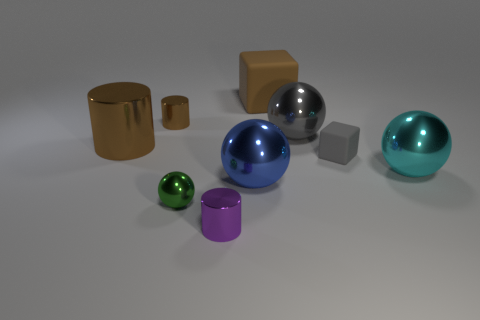Are there any small cubes left of the gray rubber cube?
Give a very brief answer. No. There is a matte block in front of the matte block that is left of the small gray rubber object behind the cyan metallic ball; how big is it?
Keep it short and to the point. Small. There is a tiny metallic thing behind the tiny rubber cube; does it have the same shape as the small metal thing that is in front of the green ball?
Your answer should be very brief. Yes. What is the size of the blue metal thing that is the same shape as the large cyan shiny thing?
Provide a succinct answer. Large. What number of large green spheres are the same material as the purple thing?
Your answer should be compact. 0. What material is the big cylinder?
Give a very brief answer. Metal. What shape is the rubber thing behind the small shiny cylinder that is behind the large gray object?
Your response must be concise. Cube. What shape is the rubber object behind the gray rubber block?
Offer a very short reply. Cube. How many metal spheres have the same color as the large rubber thing?
Your answer should be compact. 0. The small metal ball is what color?
Give a very brief answer. Green. 